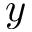<formula> <loc_0><loc_0><loc_500><loc_500>y</formula> 